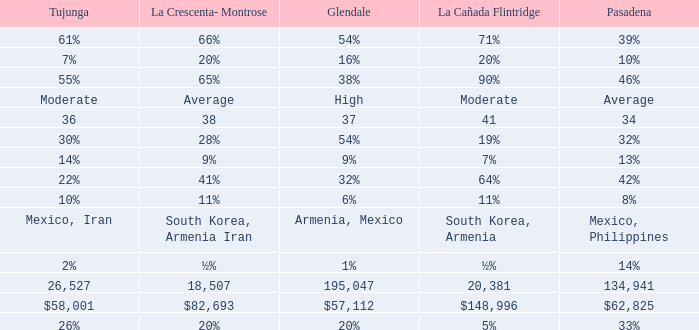What is the percentage of Glendale when Pasadena is 14%? 1%. 